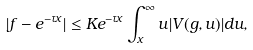Convert formula to latex. <formula><loc_0><loc_0><loc_500><loc_500>| f - e ^ { - \tau x } | \leq K e ^ { - \tau x } \int _ { x } ^ { \infty } u | V ( g , u ) | d u ,</formula> 